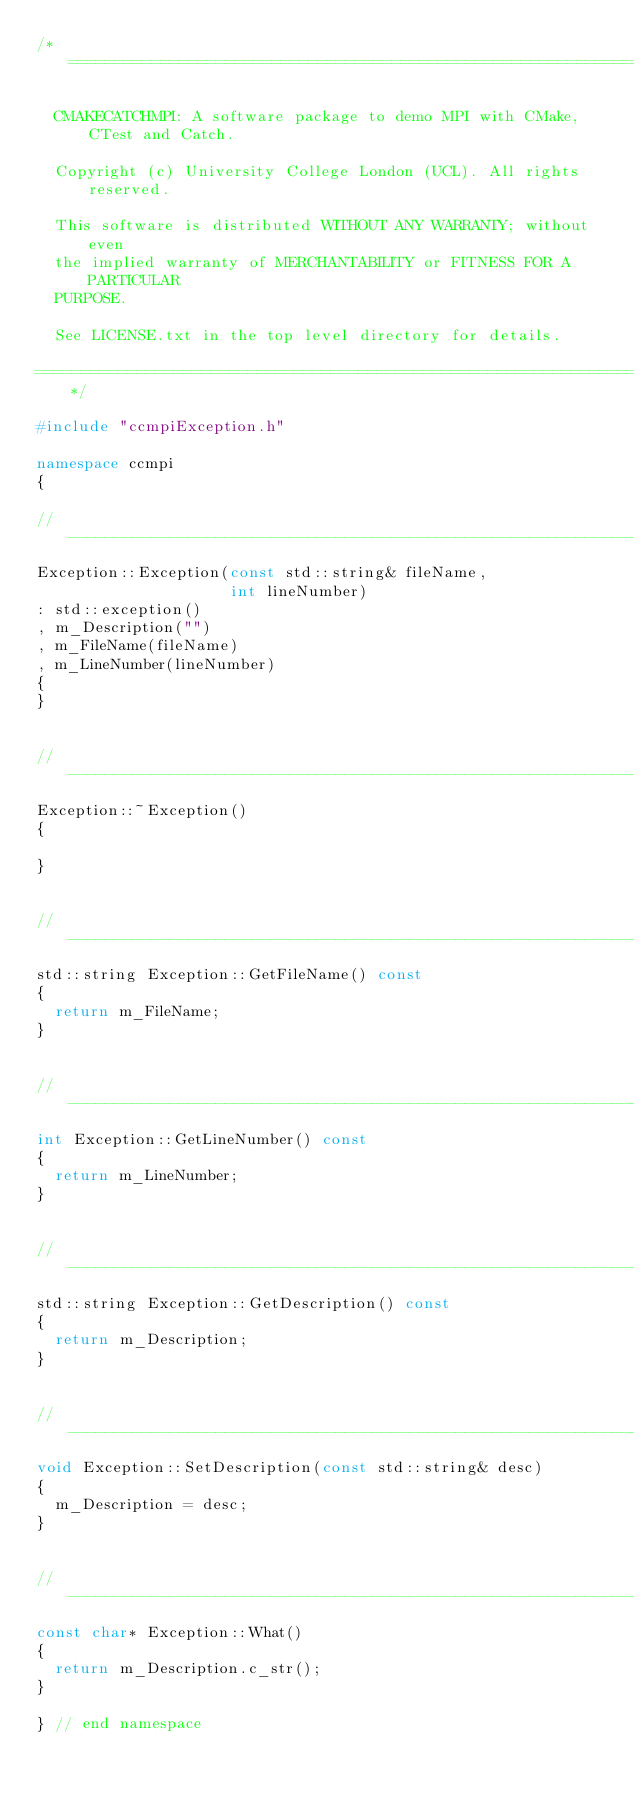<code> <loc_0><loc_0><loc_500><loc_500><_C++_>/*=============================================================================

  CMAKECATCHMPI: A software package to demo MPI with CMake, CTest and Catch.

  Copyright (c) University College London (UCL). All rights reserved.

  This software is distributed WITHOUT ANY WARRANTY; without even
  the implied warranty of MERCHANTABILITY or FITNESS FOR A PARTICULAR
  PURPOSE.

  See LICENSE.txt in the top level directory for details.

=============================================================================*/

#include "ccmpiException.h"

namespace ccmpi
{

//-----------------------------------------------------------------------------
Exception::Exception(const std::string& fileName,
                     int lineNumber)
: std::exception()
, m_Description("")
, m_FileName(fileName)
, m_LineNumber(lineNumber)
{
}


//-----------------------------------------------------------------------------
Exception::~Exception()
{

}


//-----------------------------------------------------------------------------
std::string Exception::GetFileName() const
{
  return m_FileName;
}


//-----------------------------------------------------------------------------
int Exception::GetLineNumber() const
{
  return m_LineNumber;
}


//-----------------------------------------------------------------------------
std::string Exception::GetDescription() const
{
  return m_Description;
}


//-----------------------------------------------------------------------------
void Exception::SetDescription(const std::string& desc)
{
  m_Description = desc;
}


//-----------------------------------------------------------------------------
const char* Exception::What()
{
  return m_Description.c_str();
}

} // end namespace
</code> 